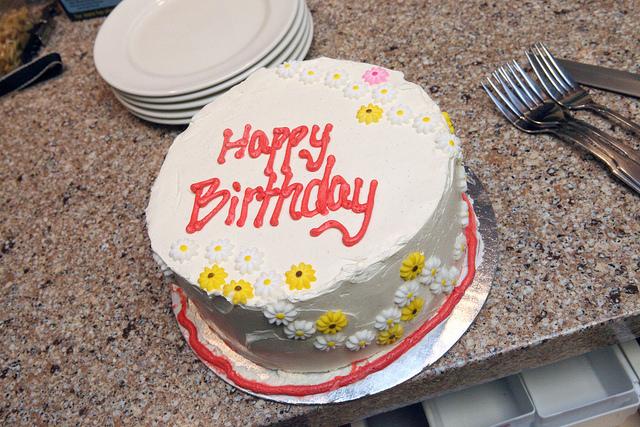Is the message on the cake written in cursive or print writing?
Be succinct. Print. What is written on the cake?
Keep it brief. Happy birthday. What type of silverware is sitting next to the cake?
Give a very brief answer. Forks. 